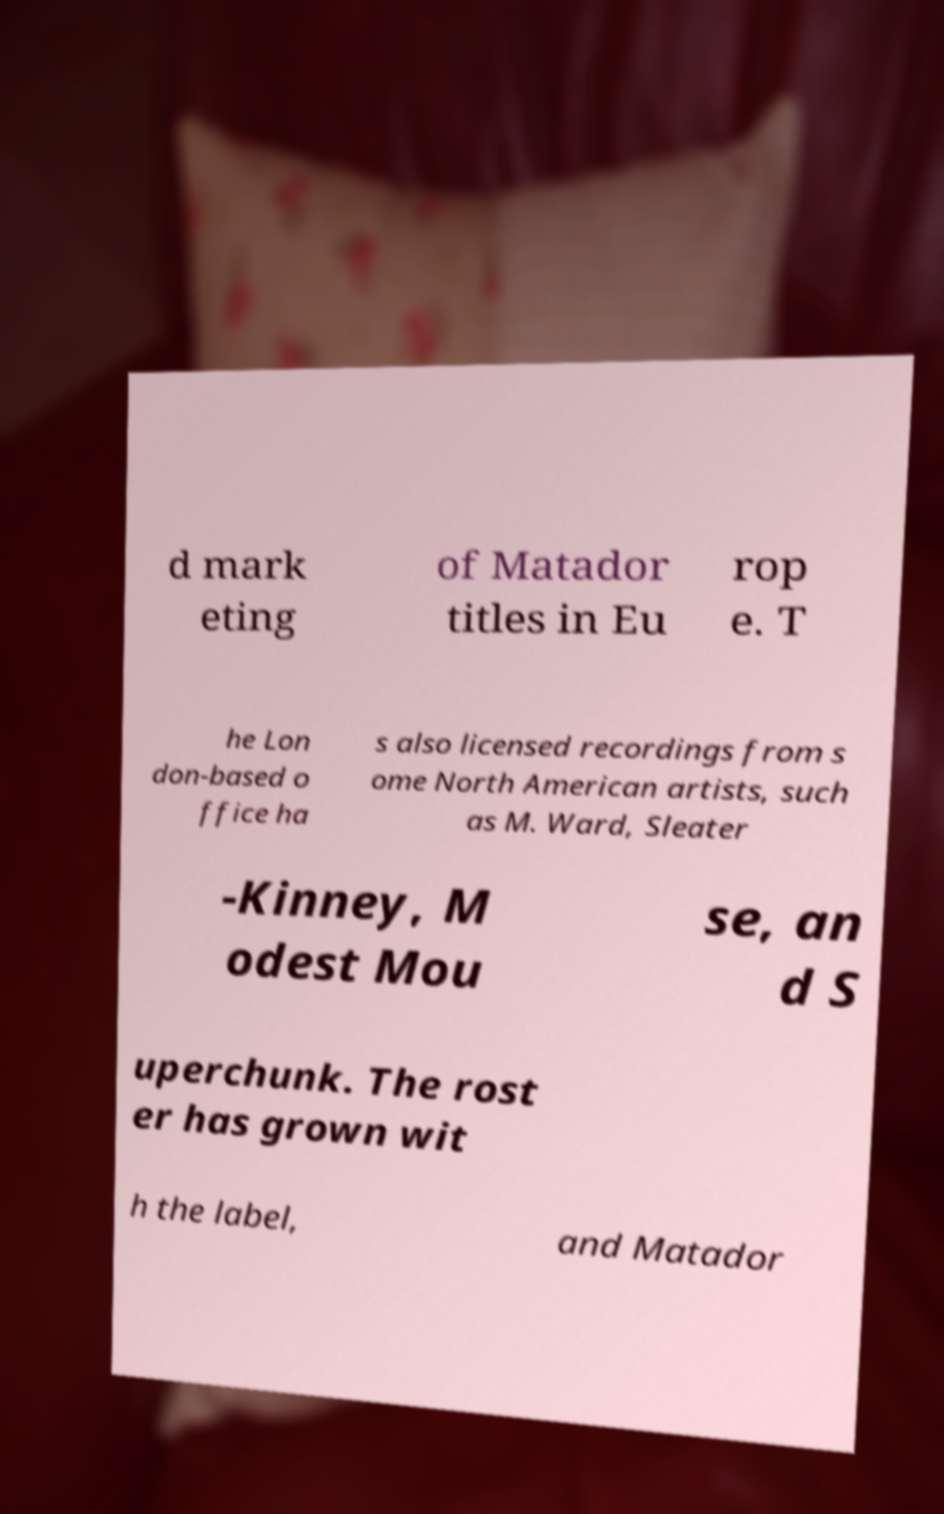For documentation purposes, I need the text within this image transcribed. Could you provide that? d mark eting of Matador titles in Eu rop e. T he Lon don-based o ffice ha s also licensed recordings from s ome North American artists, such as M. Ward, Sleater -Kinney, M odest Mou se, an d S uperchunk. The rost er has grown wit h the label, and Matador 